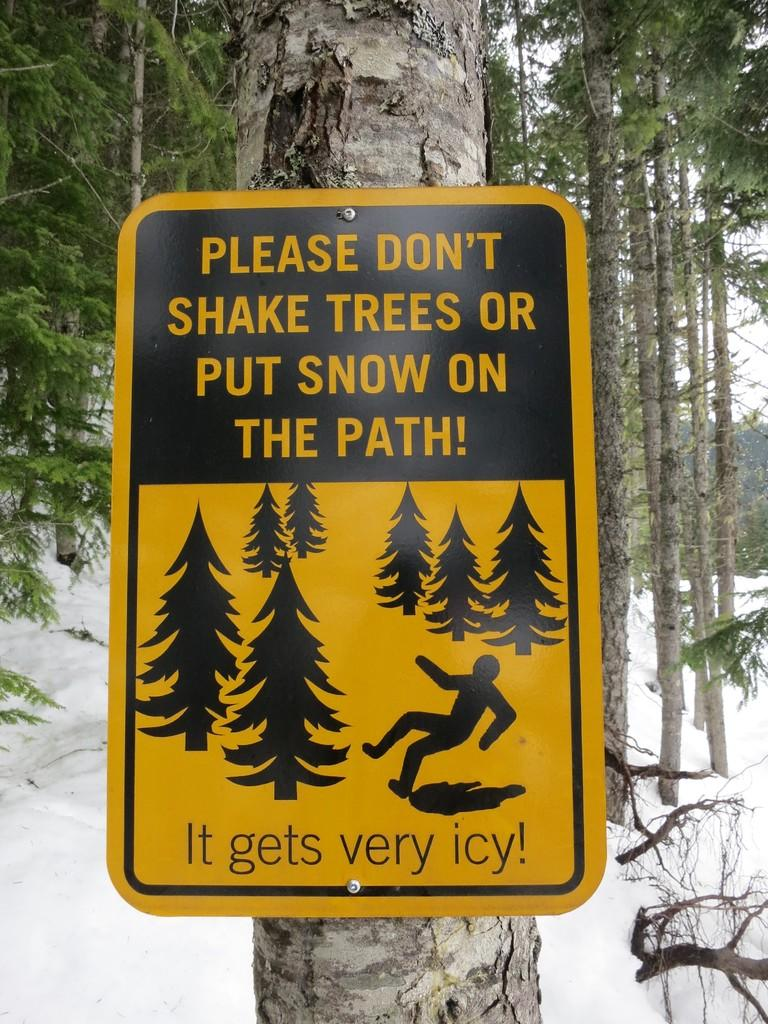What is attached to the tree in the image? There is an informational board attached to a tree in the image. What can be seen in the background of the image? There are many trees visible in the background of the image. What is the weather like in the image? There is snow present in the image, indicating a cold or wintery environment. What type of corn can be seen growing in the image? There is no corn present in the image; it features an informational board attached to a tree and snow in the background. 